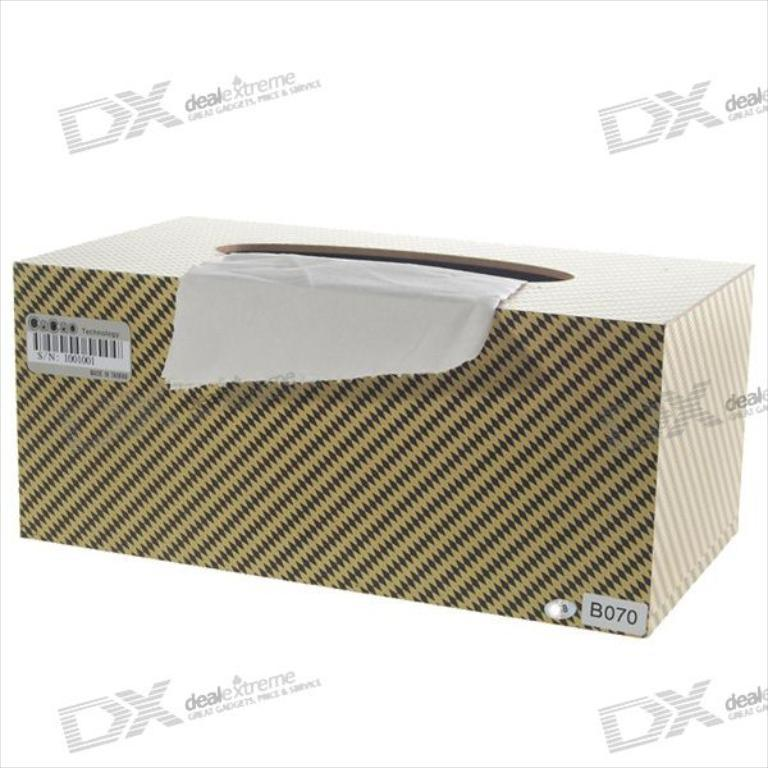<image>
Render a clear and concise summary of the photo. A box that looks like facial tissues is labeled B070. 